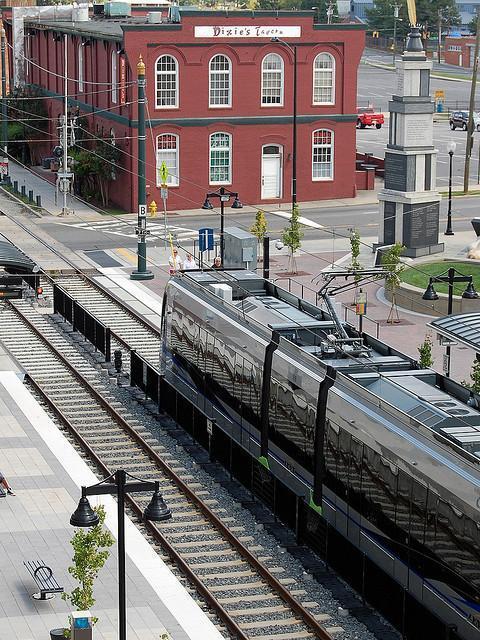How many train tracks?
Give a very brief answer. 2. 